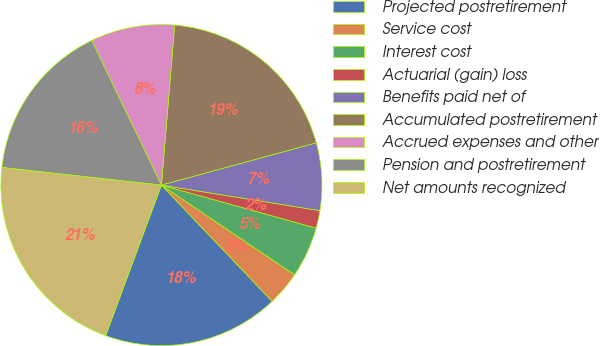Convert chart to OTSL. <chart><loc_0><loc_0><loc_500><loc_500><pie_chart><fcel>Projected postretirement<fcel>Service cost<fcel>Interest cost<fcel>Actuarial (gain) loss<fcel>Benefits paid net of<fcel>Accumulated postretirement<fcel>Accrued expenses and other<fcel>Pension and postretirement<fcel>Net amounts recognized<nl><fcel>17.76%<fcel>3.45%<fcel>5.12%<fcel>1.77%<fcel>6.79%<fcel>19.44%<fcel>8.47%<fcel>16.09%<fcel>21.11%<nl></chart> 